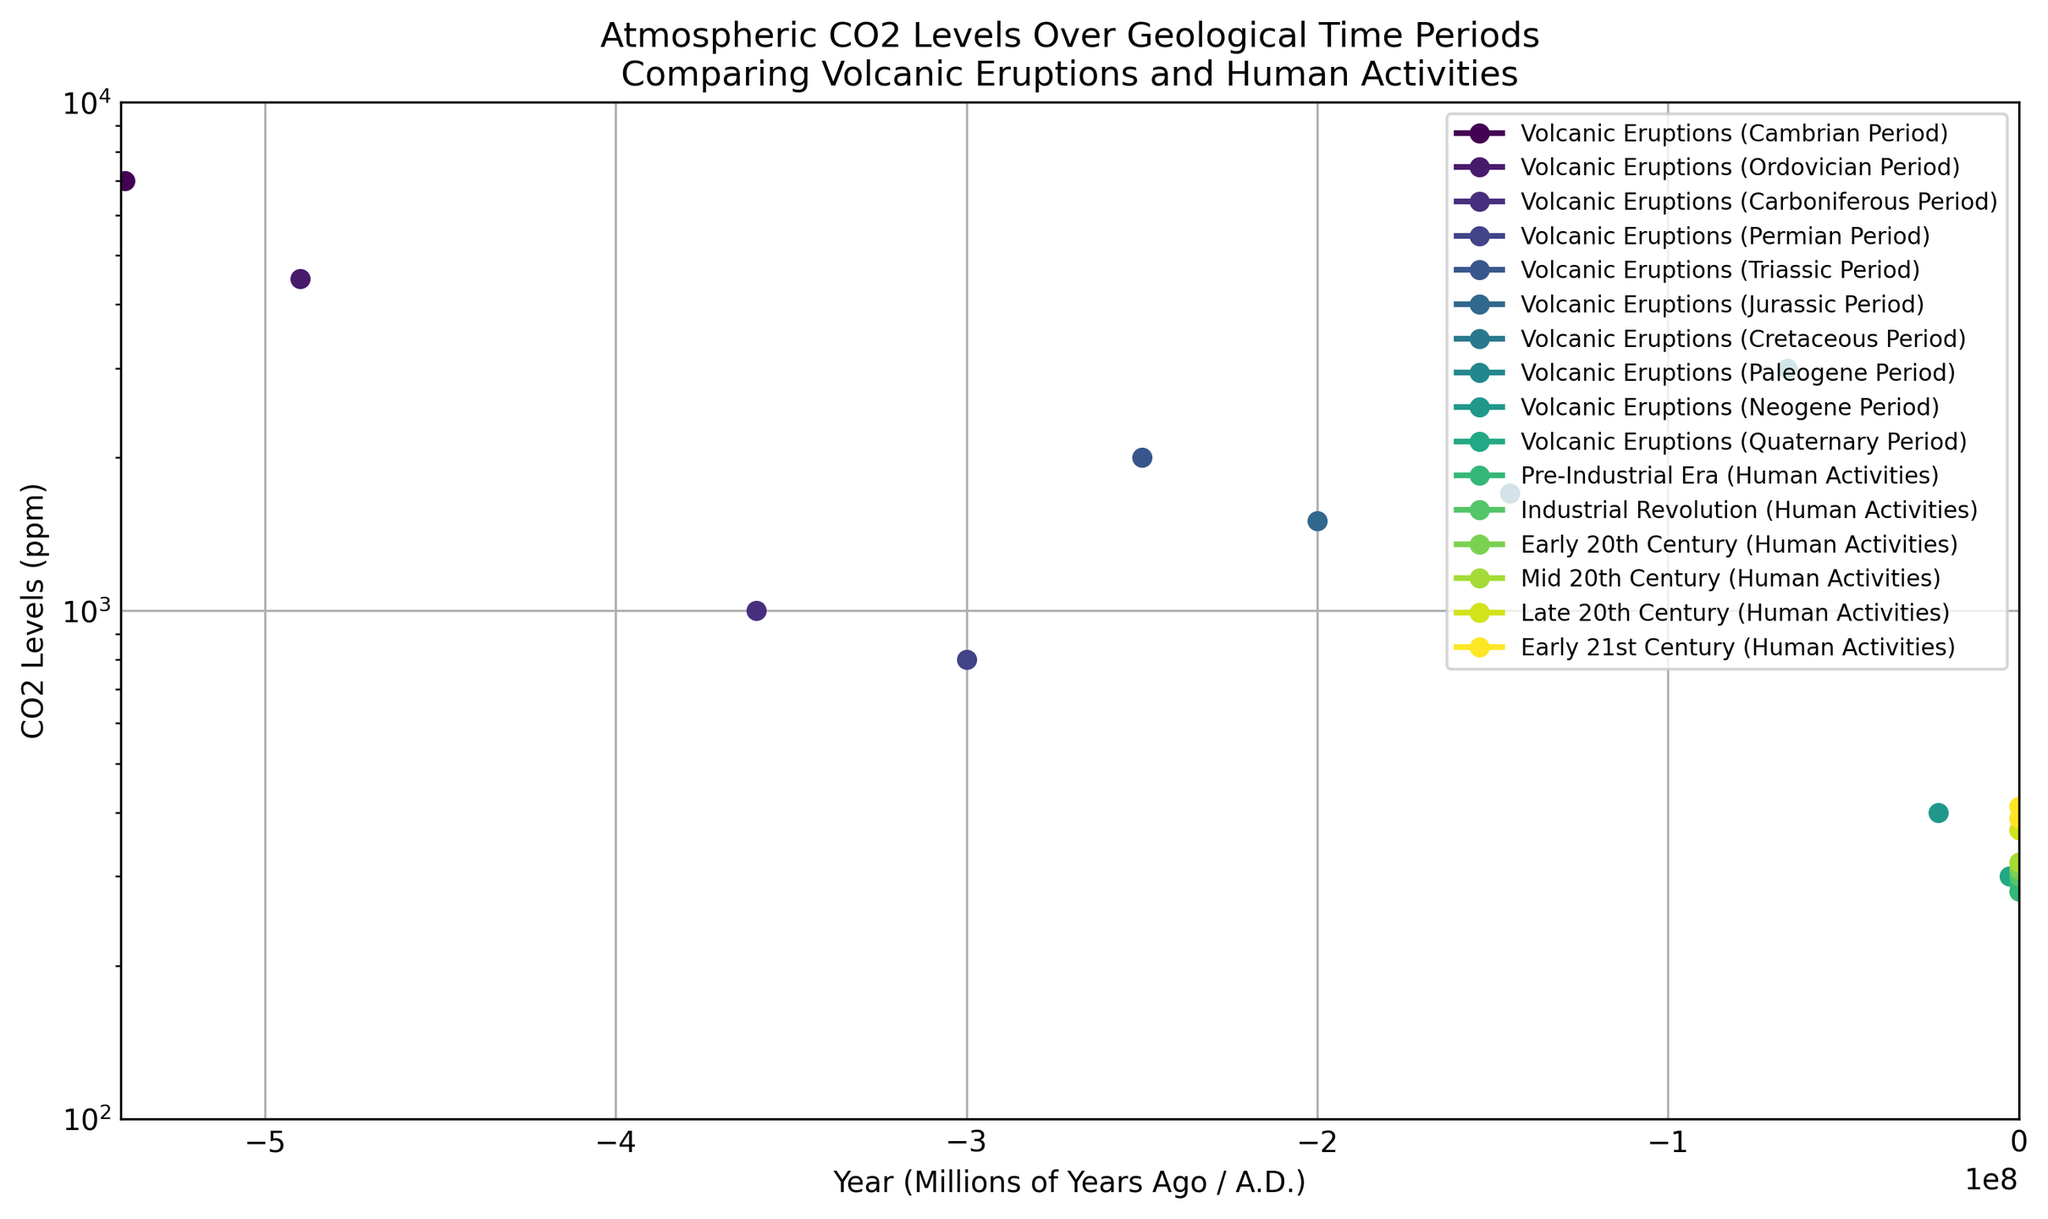What is the general trend of CO2 levels due to human activities from the Pre-Industrial Era to the Early 21st Century? The figure shows that CO2 levels due to human activities have gradually increased. Starting from 280 ppm in the Pre-Industrial Era, the levels slightly rise until around 1850, then sharply increase during the Industrial Revolution and continue to rise in the 20th and 21st centuries.
Answer: Increasing trend How do CO2 levels from volcanic eruptions during the Cambrian Period compare to the Triassic Period? During the Cambrian Period, CO2 levels were around 7000 ppm, whereas in the Triassic Period they were around 2000 ppm. This comparison shows that CO2 levels during the Cambrian Period were significantly higher than in the Triassic Period.
Answer: Cambrian Period levels are higher Which period exhibits the highest CO2 level due to volcanic eruptions? By comparing the CO2 levels during the geological periods provided, the Cambrian Period has the highest value at 7000 ppm.
Answer: Cambrian Period What is the difference in CO2 levels between the Jurassic and Cretaceous periods from volcanic eruptions? The Jurassic Period has CO2 levels of about 1500 ppm, while the Cretaceous Period levels are around 1700 ppm. The difference in CO2 levels between these two periods is 1700 - 1500 = 200 ppm.
Answer: 200 ppm In which era are the CO2 levels due to human activities first matched to or exceeded 300 ppm? Observing the graph, in the year 1900, CO2 levels due to human activities reached 310 ppm, which is the first instance where it matches or exceeds 300 ppm.
Answer: 1900 Calculate the average CO2 level due to volcanic eruptions during the Cambrian, Ordovician, and Carboniferous periods. CO2 levels are 7000 ppm (Cambrian), 4500 ppm (Ordovician), and 1000 ppm (Carboniferous). The average is calculated by (7000 + 4500 + 1000) / 3 = 12500 / 3 ≈ 4167 ppm.
Answer: 4167 ppm What is the duration in years between the peak CO2 levels in the Cambrian and the lowest CO2 levels in the Quaternary periods due to volcanic eruptions? The Cambrian period (-540000000 years) marks the peak CO2 levels at 7000 ppm, and the Quaternary period (-2600000 years) marks the lowest at 300 ppm. The duration between these periods is 540,000,000 - 2,600,000 = 537,400,000 years.
Answer: 537,400,000 years Which source, volcanic eruptions or human activities, contributes most to CO2 levels in recent periods? By comparing the color-coded data points, it's clear that in the recent periods (from mid-20th century to early 21st century), human activities' CO2 levels are more prominent, reaching 412 ppm by 2020.
Answer: Human activities How many geological time periods show CO2 levels greater than 2000 ppm due to volcanic eruptions? By examining the volcanic data points, the Cambrian (7000 ppm), Ordovician (4500 ppm), and Paleogene (3000 ppm) periods exhibit CO2 levels greater than 2000 ppm. There are 3 periods in total.
Answer: 3 periods 